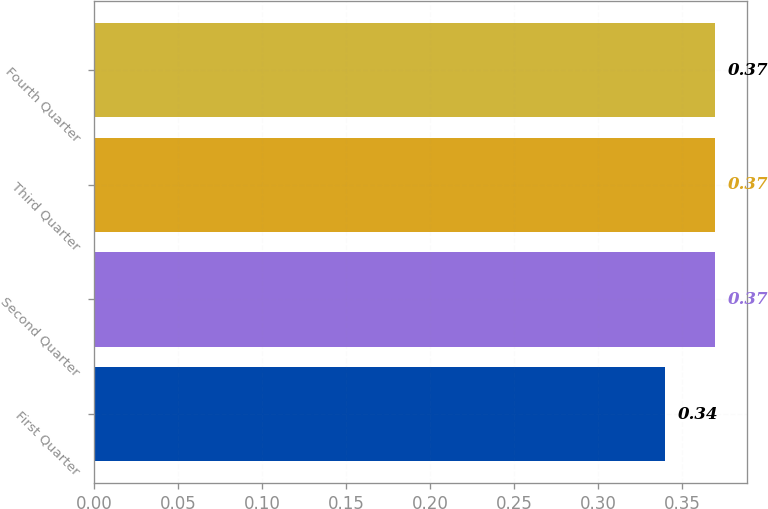Convert chart. <chart><loc_0><loc_0><loc_500><loc_500><bar_chart><fcel>First Quarter<fcel>Second Quarter<fcel>Third Quarter<fcel>Fourth Quarter<nl><fcel>0.34<fcel>0.37<fcel>0.37<fcel>0.37<nl></chart> 